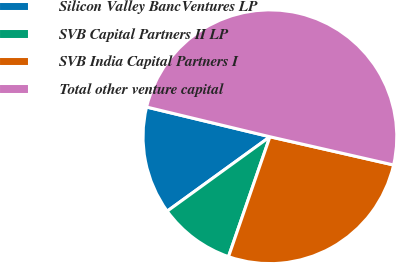<chart> <loc_0><loc_0><loc_500><loc_500><pie_chart><fcel>Silicon Valley BancVentures LP<fcel>SVB Capital Partners II LP<fcel>SVB India Capital Partners I<fcel>Total other venture capital<nl><fcel>13.74%<fcel>9.73%<fcel>26.72%<fcel>49.81%<nl></chart> 